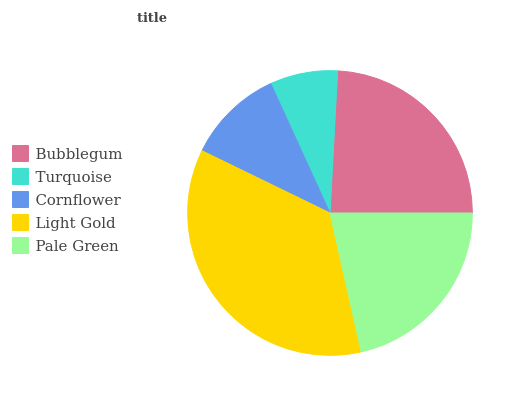Is Turquoise the minimum?
Answer yes or no. Yes. Is Light Gold the maximum?
Answer yes or no. Yes. Is Cornflower the minimum?
Answer yes or no. No. Is Cornflower the maximum?
Answer yes or no. No. Is Cornflower greater than Turquoise?
Answer yes or no. Yes. Is Turquoise less than Cornflower?
Answer yes or no. Yes. Is Turquoise greater than Cornflower?
Answer yes or no. No. Is Cornflower less than Turquoise?
Answer yes or no. No. Is Pale Green the high median?
Answer yes or no. Yes. Is Pale Green the low median?
Answer yes or no. Yes. Is Turquoise the high median?
Answer yes or no. No. Is Turquoise the low median?
Answer yes or no. No. 